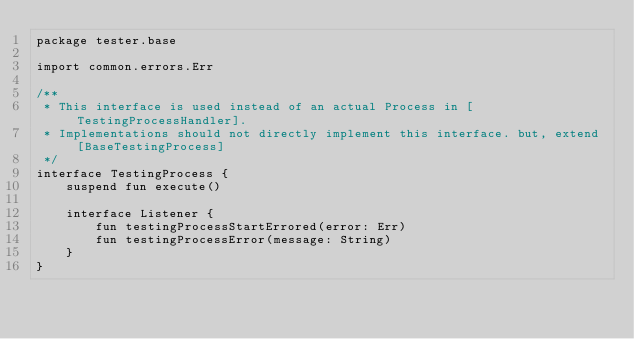Convert code to text. <code><loc_0><loc_0><loc_500><loc_500><_Kotlin_>package tester.base

import common.errors.Err

/**
 * This interface is used instead of an actual Process in [TestingProcessHandler].
 * Implementations should not directly implement this interface. but, extend [BaseTestingProcess]
 */
interface TestingProcess {
    suspend fun execute()

    interface Listener {
        fun testingProcessStartErrored(error: Err)
        fun testingProcessError(message: String)
    }
}</code> 